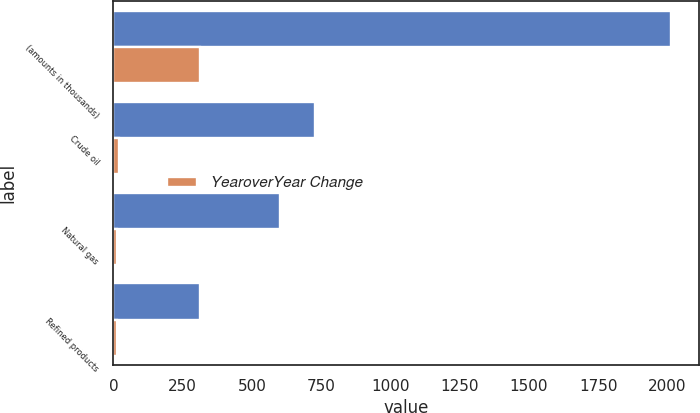Convert chart to OTSL. <chart><loc_0><loc_0><loc_500><loc_500><stacked_bar_chart><ecel><fcel>(amounts in thousands)<fcel>Crude oil<fcel>Natural gas<fcel>Refined products<nl><fcel>nan<fcel>2012<fcel>729<fcel>600<fcel>314<nl><fcel>YearoverYear Change<fcel>314<fcel>19<fcel>12<fcel>14<nl></chart> 